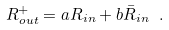Convert formula to latex. <formula><loc_0><loc_0><loc_500><loc_500>R _ { o u t } ^ { + } = a R _ { i n } + b \bar { R } _ { i n } \ .</formula> 